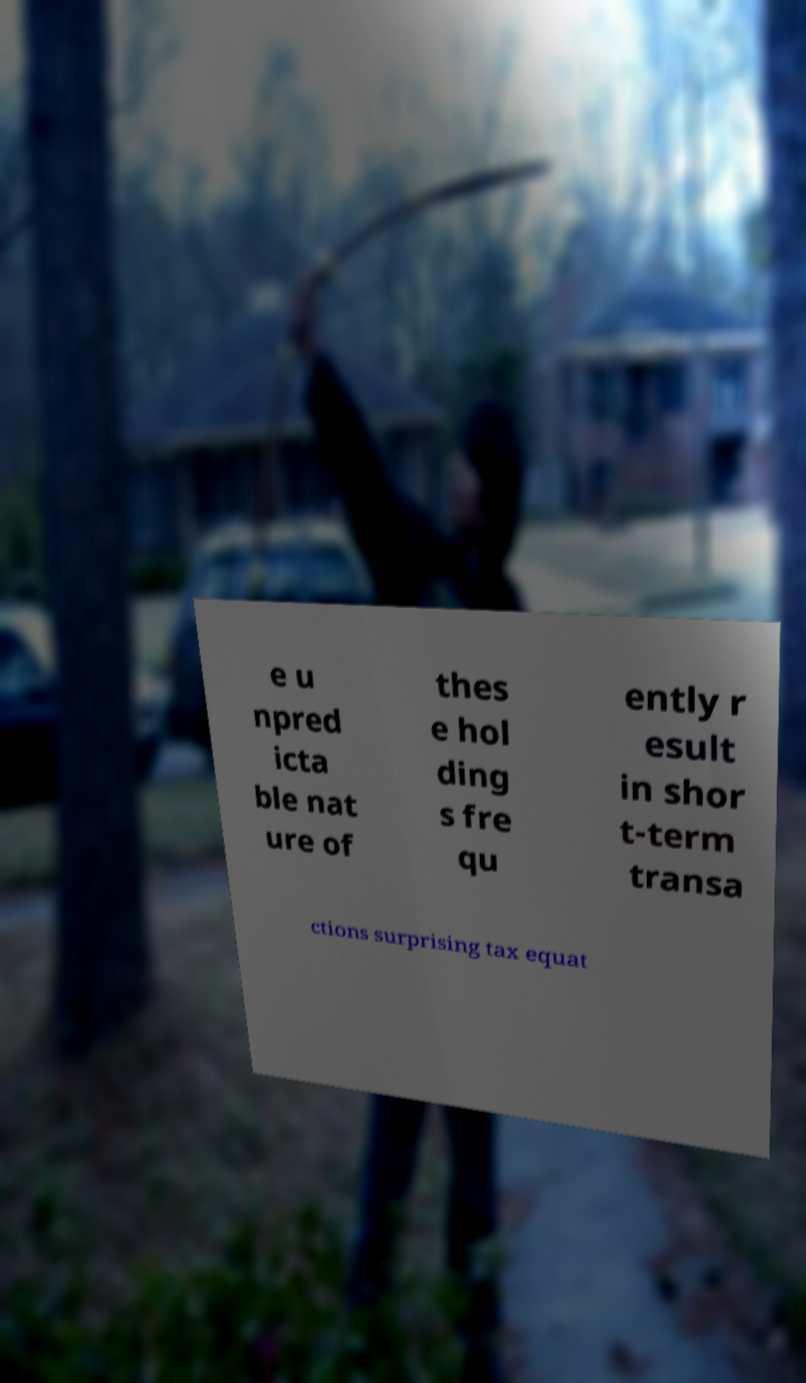Please identify and transcribe the text found in this image. e u npred icta ble nat ure of thes e hol ding s fre qu ently r esult in shor t-term transa ctions surprising tax equat 